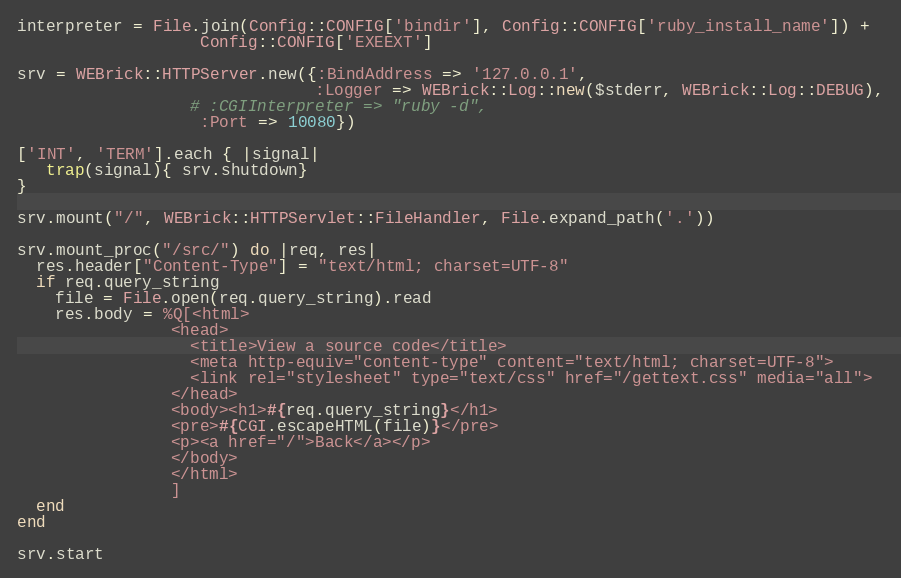<code> <loc_0><loc_0><loc_500><loc_500><_Ruby_>
interpreter = File.join(Config::CONFIG['bindir'], Config::CONFIG['ruby_install_name']) +
 			       Config::CONFIG['EXEEXT']

srv = WEBrick::HTTPServer.new({:BindAddress => '127.0.0.1',
                               :Logger => WEBrick::Log::new($stderr, WEBrick::Log::DEBUG),
			      # :CGIInterpreter => "ruby -d",
			       :Port => 10080})

['INT', 'TERM'].each { |signal|
   trap(signal){ srv.shutdown} 
}

srv.mount("/", WEBrick::HTTPServlet::FileHandler, File.expand_path('.'))

srv.mount_proc("/src/") do |req, res|
  res.header["Content-Type"] = "text/html; charset=UTF-8"
  if req.query_string
    file = File.open(req.query_string).read
    res.body = %Q[<html>
                <head>
                  <title>View a source code</title>
                  <meta http-equiv="content-type" content="text/html; charset=UTF-8">
                  <link rel="stylesheet" type="text/css" href="/gettext.css" media="all">
                </head>
                <body><h1>#{req.query_string}</h1>
                <pre>#{CGI.escapeHTML(file)}</pre>
                <p><a href="/">Back</a></p>
                </body>
                </html>
                ]
  end
end

srv.start
</code> 